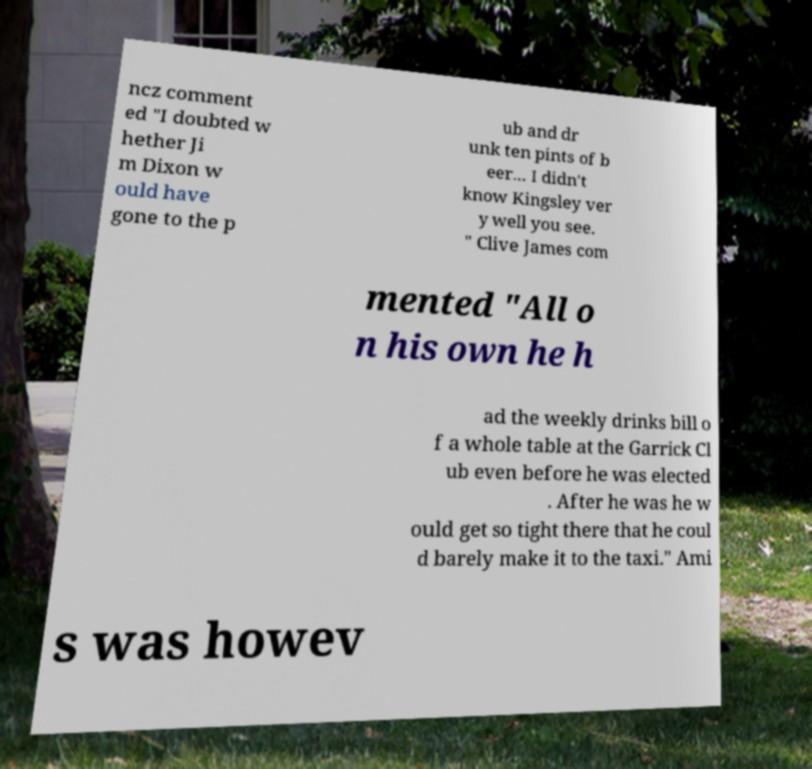Could you assist in decoding the text presented in this image and type it out clearly? ncz comment ed "I doubted w hether Ji m Dixon w ould have gone to the p ub and dr unk ten pints of b eer... I didn't know Kingsley ver y well you see. " Clive James com mented "All o n his own he h ad the weekly drinks bill o f a whole table at the Garrick Cl ub even before he was elected . After he was he w ould get so tight there that he coul d barely make it to the taxi." Ami s was howev 